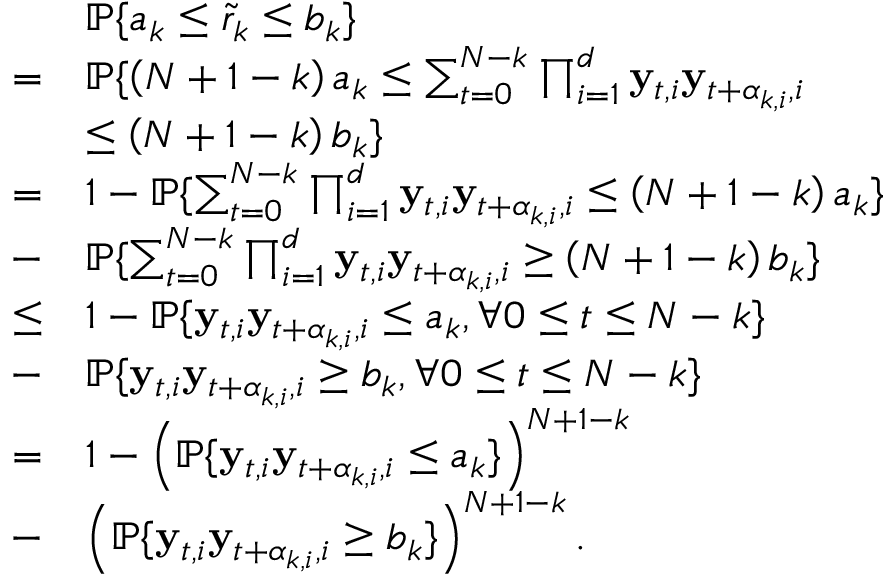<formula> <loc_0><loc_0><loc_500><loc_500>\begin{array} { r l } & { \mathbb { P } \{ a _ { k } \leq \tilde { r } _ { k } \leq b _ { k } \} } \\ { = } & { \mathbb { P } \{ \left ( N + 1 - k \right ) a _ { k } \leq \sum _ { t = 0 } ^ { N - k } \prod _ { i = 1 } ^ { d } y _ { t , i } y _ { t + \alpha _ { k , i } , i } } \\ & { \leq \left ( N + 1 - k \right ) b _ { k } \} } \\ { = } & { 1 - \mathbb { P } \{ \sum _ { t = 0 } ^ { N - k } \prod _ { i = 1 } ^ { d } y _ { t , i } y _ { t + \alpha _ { k , i } , i } \leq \left ( N + 1 - k \right ) a _ { k } \} } \\ { - } & { \mathbb { P } \{ \sum _ { t = 0 } ^ { N - k } \prod _ { i = 1 } ^ { d } y _ { t , i } y _ { t + \alpha _ { k , i } , i } \geq \left ( N + 1 - k \right ) b _ { k } \} } \\ { \leq } & { 1 - \mathbb { P } \{ y _ { t , i } y _ { t + \alpha _ { k , i } , i } \leq a _ { k } , \forall 0 \leq t \leq N - k \} } \\ { - } & { \mathbb { P } \{ y _ { t , i } y _ { t + \alpha _ { k , i } , i } \geq b _ { k } , \forall 0 \leq t \leq N - k \} } \\ { = } & { 1 - \left ( \mathbb { P } \{ y _ { t , i } y _ { t + \alpha _ { k , i } , i } \leq a _ { k } \} \right ) ^ { N + 1 - k } } \\ { - } & { \left ( \mathbb { P } \{ y _ { t , i } y _ { t + \alpha _ { k , i } , i } \geq b _ { k } \} \right ) ^ { N + 1 - k } . } \end{array}</formula> 